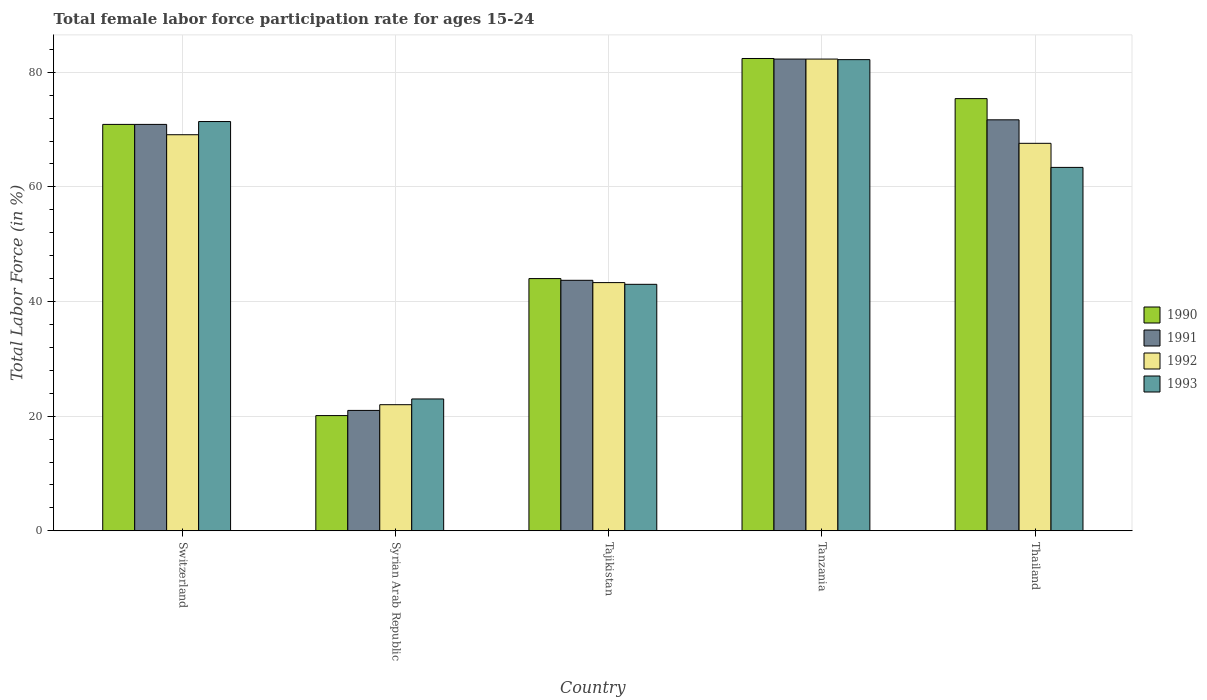How many different coloured bars are there?
Provide a succinct answer. 4. Are the number of bars per tick equal to the number of legend labels?
Provide a short and direct response. Yes. How many bars are there on the 1st tick from the left?
Give a very brief answer. 4. How many bars are there on the 2nd tick from the right?
Offer a terse response. 4. What is the label of the 4th group of bars from the left?
Offer a very short reply. Tanzania. What is the female labor force participation rate in 1993 in Switzerland?
Offer a very short reply. 71.4. Across all countries, what is the maximum female labor force participation rate in 1992?
Your response must be concise. 82.3. Across all countries, what is the minimum female labor force participation rate in 1991?
Give a very brief answer. 21. In which country was the female labor force participation rate in 1991 maximum?
Your response must be concise. Tanzania. In which country was the female labor force participation rate in 1991 minimum?
Make the answer very short. Syrian Arab Republic. What is the total female labor force participation rate in 1992 in the graph?
Keep it short and to the point. 284.3. What is the difference between the female labor force participation rate in 1992 in Syrian Arab Republic and that in Tajikistan?
Provide a short and direct response. -21.3. What is the difference between the female labor force participation rate in 1992 in Tanzania and the female labor force participation rate in 1993 in Switzerland?
Keep it short and to the point. 10.9. What is the average female labor force participation rate in 1993 per country?
Make the answer very short. 56.6. What is the difference between the female labor force participation rate of/in 1991 and female labor force participation rate of/in 1992 in Tanzania?
Make the answer very short. 0. What is the ratio of the female labor force participation rate in 1992 in Syrian Arab Republic to that in Thailand?
Your answer should be very brief. 0.33. What is the difference between the highest and the second highest female labor force participation rate in 1991?
Provide a short and direct response. 11.4. What is the difference between the highest and the lowest female labor force participation rate in 1992?
Give a very brief answer. 60.3. Is it the case that in every country, the sum of the female labor force participation rate in 1993 and female labor force participation rate in 1992 is greater than the sum of female labor force participation rate in 1991 and female labor force participation rate in 1990?
Provide a succinct answer. No. What does the 4th bar from the right in Switzerland represents?
Ensure brevity in your answer.  1990. Is it the case that in every country, the sum of the female labor force participation rate in 1991 and female labor force participation rate in 1990 is greater than the female labor force participation rate in 1993?
Offer a very short reply. Yes. How many bars are there?
Make the answer very short. 20. Are the values on the major ticks of Y-axis written in scientific E-notation?
Ensure brevity in your answer.  No. Does the graph contain any zero values?
Provide a short and direct response. No. Where does the legend appear in the graph?
Ensure brevity in your answer.  Center right. What is the title of the graph?
Your answer should be compact. Total female labor force participation rate for ages 15-24. What is the label or title of the X-axis?
Your answer should be compact. Country. What is the Total Labor Force (in %) of 1990 in Switzerland?
Your answer should be very brief. 70.9. What is the Total Labor Force (in %) in 1991 in Switzerland?
Give a very brief answer. 70.9. What is the Total Labor Force (in %) of 1992 in Switzerland?
Offer a terse response. 69.1. What is the Total Labor Force (in %) of 1993 in Switzerland?
Give a very brief answer. 71.4. What is the Total Labor Force (in %) of 1990 in Syrian Arab Republic?
Ensure brevity in your answer.  20.1. What is the Total Labor Force (in %) of 1991 in Syrian Arab Republic?
Ensure brevity in your answer.  21. What is the Total Labor Force (in %) of 1992 in Syrian Arab Republic?
Offer a terse response. 22. What is the Total Labor Force (in %) in 1993 in Syrian Arab Republic?
Your answer should be very brief. 23. What is the Total Labor Force (in %) of 1991 in Tajikistan?
Provide a short and direct response. 43.7. What is the Total Labor Force (in %) in 1992 in Tajikistan?
Offer a very short reply. 43.3. What is the Total Labor Force (in %) of 1990 in Tanzania?
Give a very brief answer. 82.4. What is the Total Labor Force (in %) of 1991 in Tanzania?
Your response must be concise. 82.3. What is the Total Labor Force (in %) in 1992 in Tanzania?
Provide a short and direct response. 82.3. What is the Total Labor Force (in %) in 1993 in Tanzania?
Make the answer very short. 82.2. What is the Total Labor Force (in %) of 1990 in Thailand?
Provide a succinct answer. 75.4. What is the Total Labor Force (in %) of 1991 in Thailand?
Keep it short and to the point. 71.7. What is the Total Labor Force (in %) in 1992 in Thailand?
Your response must be concise. 67.6. What is the Total Labor Force (in %) in 1993 in Thailand?
Your answer should be very brief. 63.4. Across all countries, what is the maximum Total Labor Force (in %) in 1990?
Your answer should be very brief. 82.4. Across all countries, what is the maximum Total Labor Force (in %) in 1991?
Offer a very short reply. 82.3. Across all countries, what is the maximum Total Labor Force (in %) of 1992?
Give a very brief answer. 82.3. Across all countries, what is the maximum Total Labor Force (in %) of 1993?
Provide a short and direct response. 82.2. Across all countries, what is the minimum Total Labor Force (in %) of 1990?
Provide a short and direct response. 20.1. What is the total Total Labor Force (in %) of 1990 in the graph?
Make the answer very short. 292.8. What is the total Total Labor Force (in %) in 1991 in the graph?
Provide a succinct answer. 289.6. What is the total Total Labor Force (in %) of 1992 in the graph?
Offer a very short reply. 284.3. What is the total Total Labor Force (in %) in 1993 in the graph?
Keep it short and to the point. 283. What is the difference between the Total Labor Force (in %) in 1990 in Switzerland and that in Syrian Arab Republic?
Offer a terse response. 50.8. What is the difference between the Total Labor Force (in %) of 1991 in Switzerland and that in Syrian Arab Republic?
Make the answer very short. 49.9. What is the difference between the Total Labor Force (in %) of 1992 in Switzerland and that in Syrian Arab Republic?
Your response must be concise. 47.1. What is the difference between the Total Labor Force (in %) in 1993 in Switzerland and that in Syrian Arab Republic?
Offer a very short reply. 48.4. What is the difference between the Total Labor Force (in %) in 1990 in Switzerland and that in Tajikistan?
Offer a terse response. 26.9. What is the difference between the Total Labor Force (in %) in 1991 in Switzerland and that in Tajikistan?
Offer a terse response. 27.2. What is the difference between the Total Labor Force (in %) in 1992 in Switzerland and that in Tajikistan?
Offer a terse response. 25.8. What is the difference between the Total Labor Force (in %) of 1993 in Switzerland and that in Tajikistan?
Keep it short and to the point. 28.4. What is the difference between the Total Labor Force (in %) of 1990 in Switzerland and that in Tanzania?
Provide a succinct answer. -11.5. What is the difference between the Total Labor Force (in %) in 1992 in Switzerland and that in Tanzania?
Your answer should be compact. -13.2. What is the difference between the Total Labor Force (in %) of 1993 in Switzerland and that in Tanzania?
Provide a short and direct response. -10.8. What is the difference between the Total Labor Force (in %) of 1990 in Switzerland and that in Thailand?
Offer a terse response. -4.5. What is the difference between the Total Labor Force (in %) of 1992 in Switzerland and that in Thailand?
Your answer should be very brief. 1.5. What is the difference between the Total Labor Force (in %) of 1993 in Switzerland and that in Thailand?
Your response must be concise. 8. What is the difference between the Total Labor Force (in %) of 1990 in Syrian Arab Republic and that in Tajikistan?
Provide a succinct answer. -23.9. What is the difference between the Total Labor Force (in %) in 1991 in Syrian Arab Republic and that in Tajikistan?
Offer a terse response. -22.7. What is the difference between the Total Labor Force (in %) of 1992 in Syrian Arab Republic and that in Tajikistan?
Your response must be concise. -21.3. What is the difference between the Total Labor Force (in %) of 1990 in Syrian Arab Republic and that in Tanzania?
Make the answer very short. -62.3. What is the difference between the Total Labor Force (in %) of 1991 in Syrian Arab Republic and that in Tanzania?
Make the answer very short. -61.3. What is the difference between the Total Labor Force (in %) of 1992 in Syrian Arab Republic and that in Tanzania?
Your answer should be compact. -60.3. What is the difference between the Total Labor Force (in %) in 1993 in Syrian Arab Republic and that in Tanzania?
Give a very brief answer. -59.2. What is the difference between the Total Labor Force (in %) in 1990 in Syrian Arab Republic and that in Thailand?
Ensure brevity in your answer.  -55.3. What is the difference between the Total Labor Force (in %) in 1991 in Syrian Arab Republic and that in Thailand?
Provide a succinct answer. -50.7. What is the difference between the Total Labor Force (in %) of 1992 in Syrian Arab Republic and that in Thailand?
Offer a very short reply. -45.6. What is the difference between the Total Labor Force (in %) in 1993 in Syrian Arab Republic and that in Thailand?
Keep it short and to the point. -40.4. What is the difference between the Total Labor Force (in %) in 1990 in Tajikistan and that in Tanzania?
Provide a succinct answer. -38.4. What is the difference between the Total Labor Force (in %) in 1991 in Tajikistan and that in Tanzania?
Your response must be concise. -38.6. What is the difference between the Total Labor Force (in %) in 1992 in Tajikistan and that in Tanzania?
Your answer should be very brief. -39. What is the difference between the Total Labor Force (in %) in 1993 in Tajikistan and that in Tanzania?
Offer a very short reply. -39.2. What is the difference between the Total Labor Force (in %) in 1990 in Tajikistan and that in Thailand?
Provide a succinct answer. -31.4. What is the difference between the Total Labor Force (in %) in 1992 in Tajikistan and that in Thailand?
Give a very brief answer. -24.3. What is the difference between the Total Labor Force (in %) of 1993 in Tajikistan and that in Thailand?
Give a very brief answer. -20.4. What is the difference between the Total Labor Force (in %) of 1992 in Tanzania and that in Thailand?
Your answer should be compact. 14.7. What is the difference between the Total Labor Force (in %) of 1990 in Switzerland and the Total Labor Force (in %) of 1991 in Syrian Arab Republic?
Your answer should be very brief. 49.9. What is the difference between the Total Labor Force (in %) of 1990 in Switzerland and the Total Labor Force (in %) of 1992 in Syrian Arab Republic?
Offer a terse response. 48.9. What is the difference between the Total Labor Force (in %) of 1990 in Switzerland and the Total Labor Force (in %) of 1993 in Syrian Arab Republic?
Make the answer very short. 47.9. What is the difference between the Total Labor Force (in %) of 1991 in Switzerland and the Total Labor Force (in %) of 1992 in Syrian Arab Republic?
Your answer should be very brief. 48.9. What is the difference between the Total Labor Force (in %) in 1991 in Switzerland and the Total Labor Force (in %) in 1993 in Syrian Arab Republic?
Your answer should be compact. 47.9. What is the difference between the Total Labor Force (in %) of 1992 in Switzerland and the Total Labor Force (in %) of 1993 in Syrian Arab Republic?
Your answer should be very brief. 46.1. What is the difference between the Total Labor Force (in %) of 1990 in Switzerland and the Total Labor Force (in %) of 1991 in Tajikistan?
Offer a very short reply. 27.2. What is the difference between the Total Labor Force (in %) of 1990 in Switzerland and the Total Labor Force (in %) of 1992 in Tajikistan?
Offer a very short reply. 27.6. What is the difference between the Total Labor Force (in %) in 1990 in Switzerland and the Total Labor Force (in %) in 1993 in Tajikistan?
Give a very brief answer. 27.9. What is the difference between the Total Labor Force (in %) of 1991 in Switzerland and the Total Labor Force (in %) of 1992 in Tajikistan?
Provide a short and direct response. 27.6. What is the difference between the Total Labor Force (in %) in 1991 in Switzerland and the Total Labor Force (in %) in 1993 in Tajikistan?
Give a very brief answer. 27.9. What is the difference between the Total Labor Force (in %) of 1992 in Switzerland and the Total Labor Force (in %) of 1993 in Tajikistan?
Keep it short and to the point. 26.1. What is the difference between the Total Labor Force (in %) in 1990 in Switzerland and the Total Labor Force (in %) in 1993 in Tanzania?
Offer a very short reply. -11.3. What is the difference between the Total Labor Force (in %) in 1991 in Switzerland and the Total Labor Force (in %) in 1992 in Tanzania?
Keep it short and to the point. -11.4. What is the difference between the Total Labor Force (in %) in 1991 in Switzerland and the Total Labor Force (in %) in 1993 in Tanzania?
Offer a very short reply. -11.3. What is the difference between the Total Labor Force (in %) in 1990 in Switzerland and the Total Labor Force (in %) in 1992 in Thailand?
Keep it short and to the point. 3.3. What is the difference between the Total Labor Force (in %) of 1990 in Switzerland and the Total Labor Force (in %) of 1993 in Thailand?
Make the answer very short. 7.5. What is the difference between the Total Labor Force (in %) of 1991 in Switzerland and the Total Labor Force (in %) of 1992 in Thailand?
Your response must be concise. 3.3. What is the difference between the Total Labor Force (in %) of 1991 in Switzerland and the Total Labor Force (in %) of 1993 in Thailand?
Your answer should be very brief. 7.5. What is the difference between the Total Labor Force (in %) of 1992 in Switzerland and the Total Labor Force (in %) of 1993 in Thailand?
Your answer should be very brief. 5.7. What is the difference between the Total Labor Force (in %) of 1990 in Syrian Arab Republic and the Total Labor Force (in %) of 1991 in Tajikistan?
Your response must be concise. -23.6. What is the difference between the Total Labor Force (in %) of 1990 in Syrian Arab Republic and the Total Labor Force (in %) of 1992 in Tajikistan?
Your answer should be compact. -23.2. What is the difference between the Total Labor Force (in %) of 1990 in Syrian Arab Republic and the Total Labor Force (in %) of 1993 in Tajikistan?
Provide a short and direct response. -22.9. What is the difference between the Total Labor Force (in %) of 1991 in Syrian Arab Republic and the Total Labor Force (in %) of 1992 in Tajikistan?
Your answer should be compact. -22.3. What is the difference between the Total Labor Force (in %) in 1992 in Syrian Arab Republic and the Total Labor Force (in %) in 1993 in Tajikistan?
Your response must be concise. -21. What is the difference between the Total Labor Force (in %) in 1990 in Syrian Arab Republic and the Total Labor Force (in %) in 1991 in Tanzania?
Provide a short and direct response. -62.2. What is the difference between the Total Labor Force (in %) of 1990 in Syrian Arab Republic and the Total Labor Force (in %) of 1992 in Tanzania?
Offer a very short reply. -62.2. What is the difference between the Total Labor Force (in %) in 1990 in Syrian Arab Republic and the Total Labor Force (in %) in 1993 in Tanzania?
Ensure brevity in your answer.  -62.1. What is the difference between the Total Labor Force (in %) of 1991 in Syrian Arab Republic and the Total Labor Force (in %) of 1992 in Tanzania?
Give a very brief answer. -61.3. What is the difference between the Total Labor Force (in %) in 1991 in Syrian Arab Republic and the Total Labor Force (in %) in 1993 in Tanzania?
Give a very brief answer. -61.2. What is the difference between the Total Labor Force (in %) in 1992 in Syrian Arab Republic and the Total Labor Force (in %) in 1993 in Tanzania?
Provide a short and direct response. -60.2. What is the difference between the Total Labor Force (in %) in 1990 in Syrian Arab Republic and the Total Labor Force (in %) in 1991 in Thailand?
Make the answer very short. -51.6. What is the difference between the Total Labor Force (in %) in 1990 in Syrian Arab Republic and the Total Labor Force (in %) in 1992 in Thailand?
Provide a short and direct response. -47.5. What is the difference between the Total Labor Force (in %) in 1990 in Syrian Arab Republic and the Total Labor Force (in %) in 1993 in Thailand?
Provide a succinct answer. -43.3. What is the difference between the Total Labor Force (in %) of 1991 in Syrian Arab Republic and the Total Labor Force (in %) of 1992 in Thailand?
Offer a terse response. -46.6. What is the difference between the Total Labor Force (in %) of 1991 in Syrian Arab Republic and the Total Labor Force (in %) of 1993 in Thailand?
Offer a terse response. -42.4. What is the difference between the Total Labor Force (in %) in 1992 in Syrian Arab Republic and the Total Labor Force (in %) in 1993 in Thailand?
Provide a succinct answer. -41.4. What is the difference between the Total Labor Force (in %) in 1990 in Tajikistan and the Total Labor Force (in %) in 1991 in Tanzania?
Your answer should be compact. -38.3. What is the difference between the Total Labor Force (in %) in 1990 in Tajikistan and the Total Labor Force (in %) in 1992 in Tanzania?
Keep it short and to the point. -38.3. What is the difference between the Total Labor Force (in %) in 1990 in Tajikistan and the Total Labor Force (in %) in 1993 in Tanzania?
Your answer should be very brief. -38.2. What is the difference between the Total Labor Force (in %) of 1991 in Tajikistan and the Total Labor Force (in %) of 1992 in Tanzania?
Offer a very short reply. -38.6. What is the difference between the Total Labor Force (in %) of 1991 in Tajikistan and the Total Labor Force (in %) of 1993 in Tanzania?
Give a very brief answer. -38.5. What is the difference between the Total Labor Force (in %) in 1992 in Tajikistan and the Total Labor Force (in %) in 1993 in Tanzania?
Give a very brief answer. -38.9. What is the difference between the Total Labor Force (in %) of 1990 in Tajikistan and the Total Labor Force (in %) of 1991 in Thailand?
Keep it short and to the point. -27.7. What is the difference between the Total Labor Force (in %) in 1990 in Tajikistan and the Total Labor Force (in %) in 1992 in Thailand?
Keep it short and to the point. -23.6. What is the difference between the Total Labor Force (in %) in 1990 in Tajikistan and the Total Labor Force (in %) in 1993 in Thailand?
Keep it short and to the point. -19.4. What is the difference between the Total Labor Force (in %) of 1991 in Tajikistan and the Total Labor Force (in %) of 1992 in Thailand?
Your response must be concise. -23.9. What is the difference between the Total Labor Force (in %) of 1991 in Tajikistan and the Total Labor Force (in %) of 1993 in Thailand?
Provide a succinct answer. -19.7. What is the difference between the Total Labor Force (in %) in 1992 in Tajikistan and the Total Labor Force (in %) in 1993 in Thailand?
Make the answer very short. -20.1. What is the difference between the Total Labor Force (in %) of 1990 in Tanzania and the Total Labor Force (in %) of 1991 in Thailand?
Keep it short and to the point. 10.7. What is the difference between the Total Labor Force (in %) in 1990 in Tanzania and the Total Labor Force (in %) in 1992 in Thailand?
Make the answer very short. 14.8. What is the difference between the Total Labor Force (in %) in 1990 in Tanzania and the Total Labor Force (in %) in 1993 in Thailand?
Provide a succinct answer. 19. What is the average Total Labor Force (in %) in 1990 per country?
Ensure brevity in your answer.  58.56. What is the average Total Labor Force (in %) in 1991 per country?
Your answer should be very brief. 57.92. What is the average Total Labor Force (in %) of 1992 per country?
Give a very brief answer. 56.86. What is the average Total Labor Force (in %) of 1993 per country?
Your response must be concise. 56.6. What is the difference between the Total Labor Force (in %) in 1991 and Total Labor Force (in %) in 1993 in Switzerland?
Your response must be concise. -0.5. What is the difference between the Total Labor Force (in %) of 1992 and Total Labor Force (in %) of 1993 in Switzerland?
Provide a succinct answer. -2.3. What is the difference between the Total Labor Force (in %) in 1990 and Total Labor Force (in %) in 1991 in Syrian Arab Republic?
Your answer should be very brief. -0.9. What is the difference between the Total Labor Force (in %) in 1990 and Total Labor Force (in %) in 1992 in Syrian Arab Republic?
Offer a terse response. -1.9. What is the difference between the Total Labor Force (in %) in 1991 and Total Labor Force (in %) in 1992 in Syrian Arab Republic?
Give a very brief answer. -1. What is the difference between the Total Labor Force (in %) of 1992 and Total Labor Force (in %) of 1993 in Syrian Arab Republic?
Keep it short and to the point. -1. What is the difference between the Total Labor Force (in %) of 1990 and Total Labor Force (in %) of 1991 in Tajikistan?
Your answer should be compact. 0.3. What is the difference between the Total Labor Force (in %) of 1990 and Total Labor Force (in %) of 1992 in Tajikistan?
Your answer should be very brief. 0.7. What is the difference between the Total Labor Force (in %) of 1991 and Total Labor Force (in %) of 1992 in Tajikistan?
Your response must be concise. 0.4. What is the difference between the Total Labor Force (in %) in 1991 and Total Labor Force (in %) in 1993 in Tajikistan?
Your answer should be compact. 0.7. What is the difference between the Total Labor Force (in %) in 1992 and Total Labor Force (in %) in 1993 in Tajikistan?
Your answer should be very brief. 0.3. What is the difference between the Total Labor Force (in %) of 1990 and Total Labor Force (in %) of 1993 in Tanzania?
Give a very brief answer. 0.2. What is the difference between the Total Labor Force (in %) of 1991 and Total Labor Force (in %) of 1992 in Tanzania?
Offer a very short reply. 0. What is the difference between the Total Labor Force (in %) in 1991 and Total Labor Force (in %) in 1993 in Tanzania?
Offer a very short reply. 0.1. What is the difference between the Total Labor Force (in %) in 1990 and Total Labor Force (in %) in 1992 in Thailand?
Make the answer very short. 7.8. What is the difference between the Total Labor Force (in %) in 1990 and Total Labor Force (in %) in 1993 in Thailand?
Offer a very short reply. 12. What is the difference between the Total Labor Force (in %) of 1991 and Total Labor Force (in %) of 1992 in Thailand?
Your answer should be compact. 4.1. What is the difference between the Total Labor Force (in %) in 1991 and Total Labor Force (in %) in 1993 in Thailand?
Provide a short and direct response. 8.3. What is the ratio of the Total Labor Force (in %) in 1990 in Switzerland to that in Syrian Arab Republic?
Offer a terse response. 3.53. What is the ratio of the Total Labor Force (in %) in 1991 in Switzerland to that in Syrian Arab Republic?
Ensure brevity in your answer.  3.38. What is the ratio of the Total Labor Force (in %) in 1992 in Switzerland to that in Syrian Arab Republic?
Make the answer very short. 3.14. What is the ratio of the Total Labor Force (in %) of 1993 in Switzerland to that in Syrian Arab Republic?
Provide a succinct answer. 3.1. What is the ratio of the Total Labor Force (in %) in 1990 in Switzerland to that in Tajikistan?
Your response must be concise. 1.61. What is the ratio of the Total Labor Force (in %) of 1991 in Switzerland to that in Tajikistan?
Offer a terse response. 1.62. What is the ratio of the Total Labor Force (in %) of 1992 in Switzerland to that in Tajikistan?
Your answer should be very brief. 1.6. What is the ratio of the Total Labor Force (in %) in 1993 in Switzerland to that in Tajikistan?
Provide a short and direct response. 1.66. What is the ratio of the Total Labor Force (in %) in 1990 in Switzerland to that in Tanzania?
Your answer should be very brief. 0.86. What is the ratio of the Total Labor Force (in %) in 1991 in Switzerland to that in Tanzania?
Your answer should be compact. 0.86. What is the ratio of the Total Labor Force (in %) of 1992 in Switzerland to that in Tanzania?
Offer a terse response. 0.84. What is the ratio of the Total Labor Force (in %) in 1993 in Switzerland to that in Tanzania?
Make the answer very short. 0.87. What is the ratio of the Total Labor Force (in %) of 1990 in Switzerland to that in Thailand?
Provide a short and direct response. 0.94. What is the ratio of the Total Labor Force (in %) in 1991 in Switzerland to that in Thailand?
Give a very brief answer. 0.99. What is the ratio of the Total Labor Force (in %) of 1992 in Switzerland to that in Thailand?
Offer a terse response. 1.02. What is the ratio of the Total Labor Force (in %) in 1993 in Switzerland to that in Thailand?
Give a very brief answer. 1.13. What is the ratio of the Total Labor Force (in %) of 1990 in Syrian Arab Republic to that in Tajikistan?
Your response must be concise. 0.46. What is the ratio of the Total Labor Force (in %) in 1991 in Syrian Arab Republic to that in Tajikistan?
Your response must be concise. 0.48. What is the ratio of the Total Labor Force (in %) of 1992 in Syrian Arab Republic to that in Tajikistan?
Make the answer very short. 0.51. What is the ratio of the Total Labor Force (in %) of 1993 in Syrian Arab Republic to that in Tajikistan?
Your response must be concise. 0.53. What is the ratio of the Total Labor Force (in %) of 1990 in Syrian Arab Republic to that in Tanzania?
Ensure brevity in your answer.  0.24. What is the ratio of the Total Labor Force (in %) in 1991 in Syrian Arab Republic to that in Tanzania?
Ensure brevity in your answer.  0.26. What is the ratio of the Total Labor Force (in %) in 1992 in Syrian Arab Republic to that in Tanzania?
Keep it short and to the point. 0.27. What is the ratio of the Total Labor Force (in %) of 1993 in Syrian Arab Republic to that in Tanzania?
Your answer should be compact. 0.28. What is the ratio of the Total Labor Force (in %) in 1990 in Syrian Arab Republic to that in Thailand?
Give a very brief answer. 0.27. What is the ratio of the Total Labor Force (in %) of 1991 in Syrian Arab Republic to that in Thailand?
Keep it short and to the point. 0.29. What is the ratio of the Total Labor Force (in %) of 1992 in Syrian Arab Republic to that in Thailand?
Your answer should be compact. 0.33. What is the ratio of the Total Labor Force (in %) in 1993 in Syrian Arab Republic to that in Thailand?
Provide a succinct answer. 0.36. What is the ratio of the Total Labor Force (in %) in 1990 in Tajikistan to that in Tanzania?
Offer a very short reply. 0.53. What is the ratio of the Total Labor Force (in %) in 1991 in Tajikistan to that in Tanzania?
Give a very brief answer. 0.53. What is the ratio of the Total Labor Force (in %) of 1992 in Tajikistan to that in Tanzania?
Give a very brief answer. 0.53. What is the ratio of the Total Labor Force (in %) of 1993 in Tajikistan to that in Tanzania?
Offer a terse response. 0.52. What is the ratio of the Total Labor Force (in %) of 1990 in Tajikistan to that in Thailand?
Provide a short and direct response. 0.58. What is the ratio of the Total Labor Force (in %) of 1991 in Tajikistan to that in Thailand?
Your answer should be very brief. 0.61. What is the ratio of the Total Labor Force (in %) of 1992 in Tajikistan to that in Thailand?
Make the answer very short. 0.64. What is the ratio of the Total Labor Force (in %) of 1993 in Tajikistan to that in Thailand?
Provide a succinct answer. 0.68. What is the ratio of the Total Labor Force (in %) of 1990 in Tanzania to that in Thailand?
Your answer should be compact. 1.09. What is the ratio of the Total Labor Force (in %) of 1991 in Tanzania to that in Thailand?
Offer a very short reply. 1.15. What is the ratio of the Total Labor Force (in %) in 1992 in Tanzania to that in Thailand?
Keep it short and to the point. 1.22. What is the ratio of the Total Labor Force (in %) of 1993 in Tanzania to that in Thailand?
Keep it short and to the point. 1.3. What is the difference between the highest and the second highest Total Labor Force (in %) in 1992?
Keep it short and to the point. 13.2. What is the difference between the highest and the lowest Total Labor Force (in %) of 1990?
Ensure brevity in your answer.  62.3. What is the difference between the highest and the lowest Total Labor Force (in %) in 1991?
Make the answer very short. 61.3. What is the difference between the highest and the lowest Total Labor Force (in %) of 1992?
Provide a succinct answer. 60.3. What is the difference between the highest and the lowest Total Labor Force (in %) of 1993?
Ensure brevity in your answer.  59.2. 